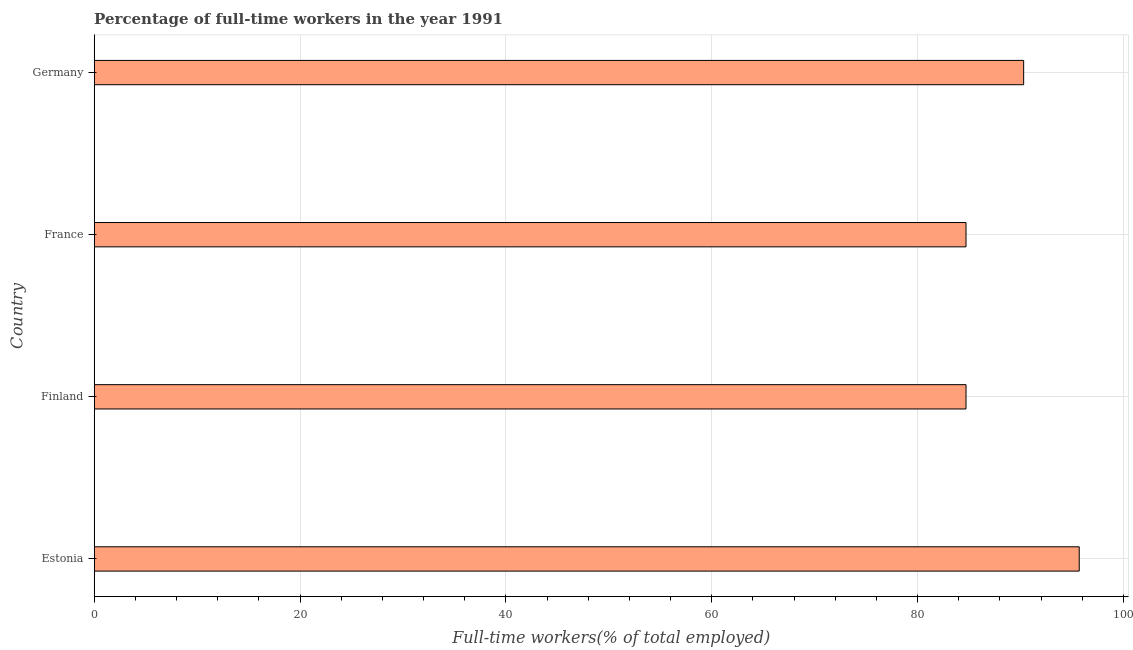What is the title of the graph?
Give a very brief answer. Percentage of full-time workers in the year 1991. What is the label or title of the X-axis?
Your answer should be compact. Full-time workers(% of total employed). What is the label or title of the Y-axis?
Your answer should be compact. Country. What is the percentage of full-time workers in Germany?
Provide a short and direct response. 90.3. Across all countries, what is the maximum percentage of full-time workers?
Give a very brief answer. 95.7. Across all countries, what is the minimum percentage of full-time workers?
Keep it short and to the point. 84.7. In which country was the percentage of full-time workers maximum?
Provide a short and direct response. Estonia. In which country was the percentage of full-time workers minimum?
Provide a succinct answer. Finland. What is the sum of the percentage of full-time workers?
Offer a very short reply. 355.4. What is the average percentage of full-time workers per country?
Offer a terse response. 88.85. What is the median percentage of full-time workers?
Ensure brevity in your answer.  87.5. Is the difference between the percentage of full-time workers in Finland and France greater than the difference between any two countries?
Provide a succinct answer. No. What is the difference between the highest and the lowest percentage of full-time workers?
Provide a short and direct response. 11. Are all the bars in the graph horizontal?
Provide a short and direct response. Yes. How many countries are there in the graph?
Offer a very short reply. 4. What is the difference between two consecutive major ticks on the X-axis?
Ensure brevity in your answer.  20. Are the values on the major ticks of X-axis written in scientific E-notation?
Your answer should be compact. No. What is the Full-time workers(% of total employed) of Estonia?
Ensure brevity in your answer.  95.7. What is the Full-time workers(% of total employed) of Finland?
Ensure brevity in your answer.  84.7. What is the Full-time workers(% of total employed) in France?
Keep it short and to the point. 84.7. What is the Full-time workers(% of total employed) in Germany?
Keep it short and to the point. 90.3. What is the difference between the Full-time workers(% of total employed) in Estonia and Finland?
Offer a terse response. 11. What is the difference between the Full-time workers(% of total employed) in Estonia and Germany?
Keep it short and to the point. 5.4. What is the difference between the Full-time workers(% of total employed) in Finland and Germany?
Your answer should be very brief. -5.6. What is the difference between the Full-time workers(% of total employed) in France and Germany?
Your answer should be compact. -5.6. What is the ratio of the Full-time workers(% of total employed) in Estonia to that in Finland?
Offer a very short reply. 1.13. What is the ratio of the Full-time workers(% of total employed) in Estonia to that in France?
Offer a very short reply. 1.13. What is the ratio of the Full-time workers(% of total employed) in Estonia to that in Germany?
Provide a succinct answer. 1.06. What is the ratio of the Full-time workers(% of total employed) in Finland to that in France?
Ensure brevity in your answer.  1. What is the ratio of the Full-time workers(% of total employed) in Finland to that in Germany?
Your answer should be very brief. 0.94. What is the ratio of the Full-time workers(% of total employed) in France to that in Germany?
Keep it short and to the point. 0.94. 